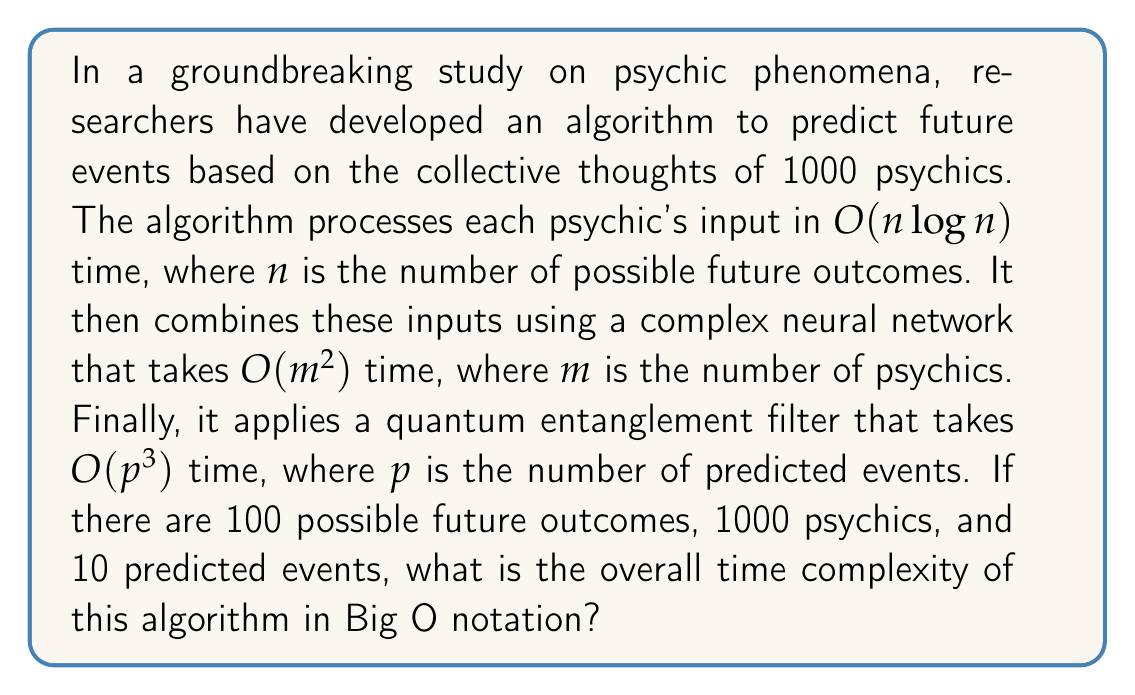Can you solve this math problem? Let's break down the algorithm's components and analyze their time complexities:

1. Processing each psychic's input:
   - Time complexity: $O(n\log n)$ per psychic
   - Number of psychics: $m = 1000$
   - Total time for this step: $O(m \cdot n\log n) = O(1000 \cdot 100\log 100)$

2. Combining inputs using neural network:
   - Time complexity: $O(m^2)$
   - $m = 1000$
   - Total time for this step: $O(1000^2)$

3. Applying quantum entanglement filter:
   - Time complexity: $O(p^3)$
   - $p = 10$
   - Total time for this step: $O(10^3)$

To determine the overall time complexity, we need to add these components:

$$O(m \cdot n\log n + m^2 + p^3)$$

Substituting the given values:

$$O(1000 \cdot 100\log 100 + 1000^2 + 10^3)$$

Simplifying:

$$O(100000\log 100 + 1000000 + 1000)$$

The dominant term in this expression is $1000000$, which comes from the $O(m^2)$ component. Therefore, the overall time complexity can be simplified to:

$$O(m^2)$$

Where $m$ is the number of psychics (1000 in this case).
Answer: $O(m^2)$, where $m$ is the number of psychics. 